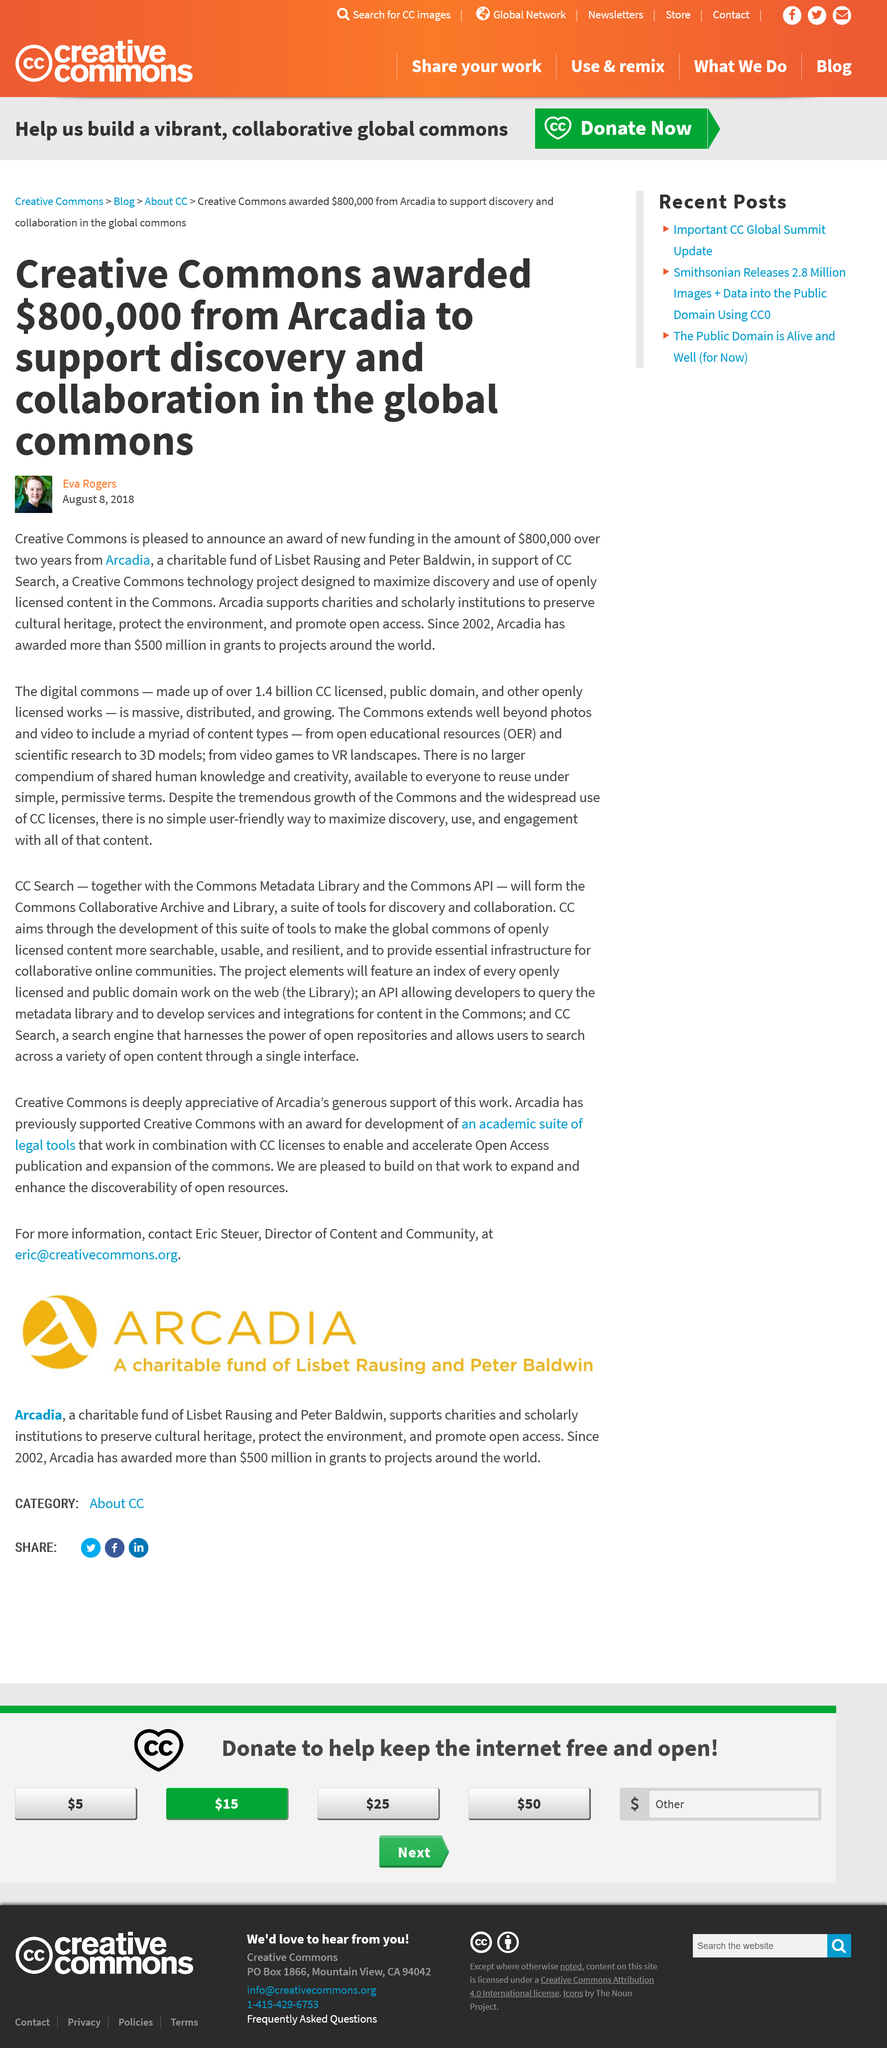Indicate a few pertinent items in this graphic. Creative Commons received an award of $800,000 from Arcadia. According to author Eva Rodgers, Arcadia has provided grants to projects globally, with a total sum of $500 million awarded to these initiatives. Arcadia provides support to charities and scholarly institutions to preserve cultural heritage, protect the environment, and promote open access. 